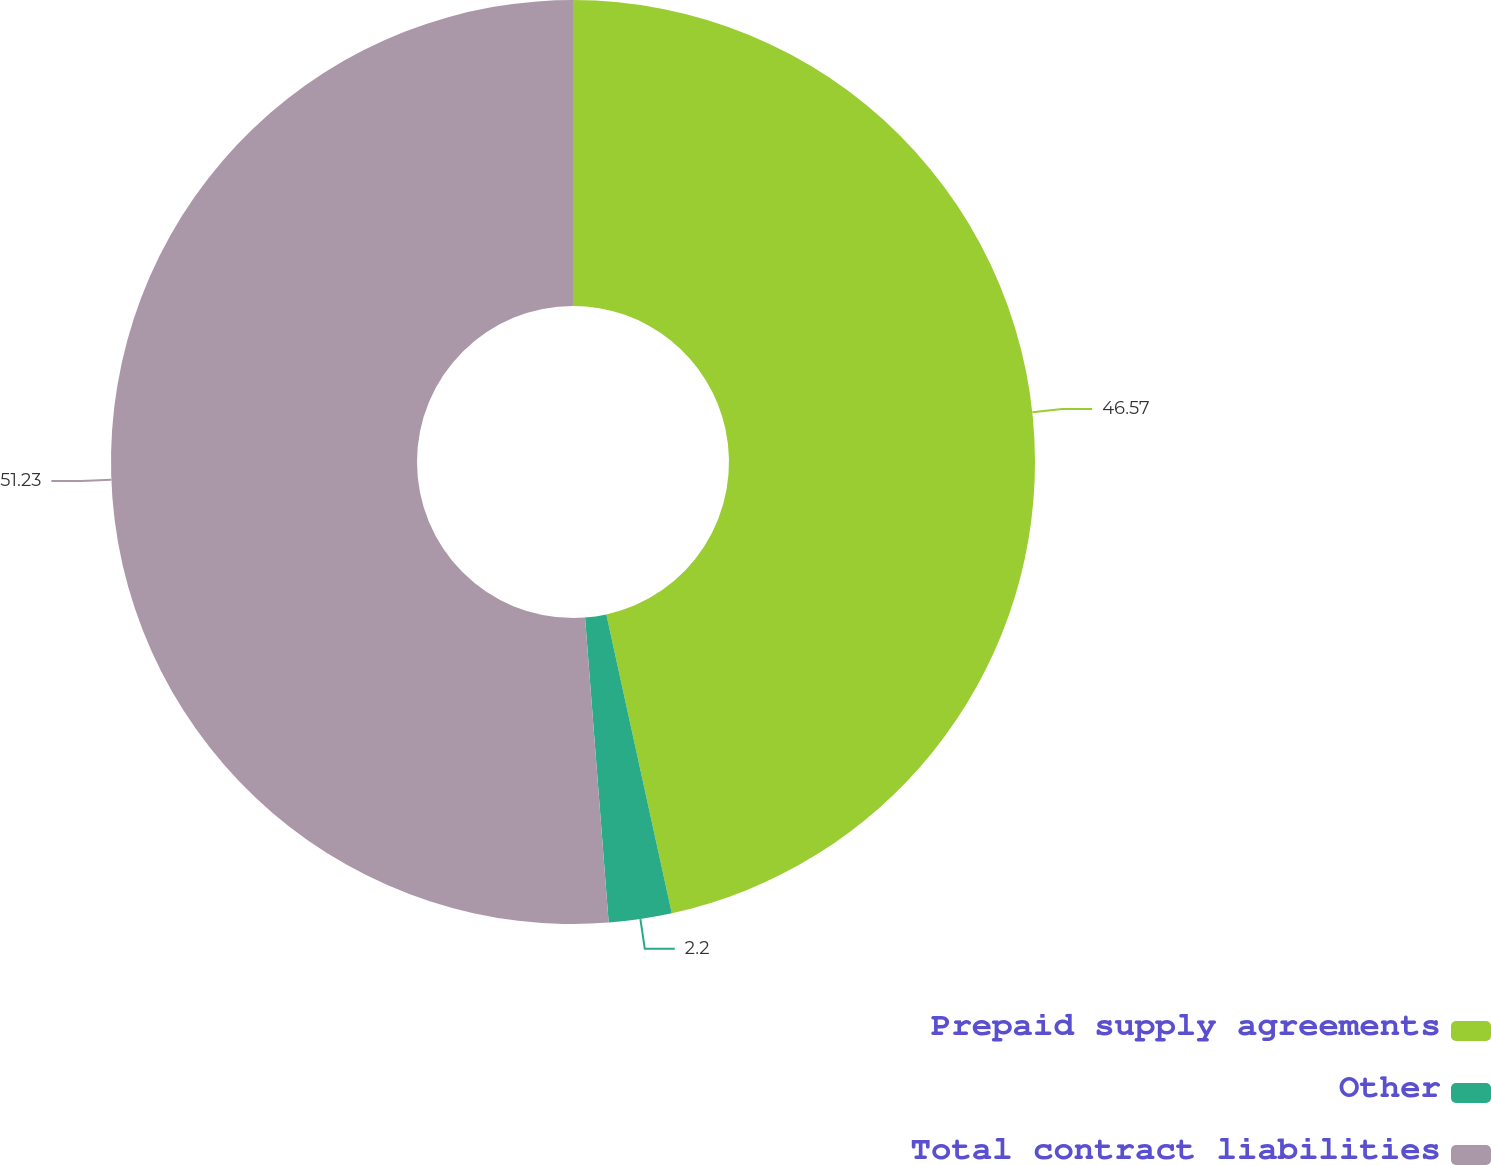Convert chart to OTSL. <chart><loc_0><loc_0><loc_500><loc_500><pie_chart><fcel>Prepaid supply agreements<fcel>Other<fcel>Total contract liabilities<nl><fcel>46.57%<fcel>2.2%<fcel>51.23%<nl></chart> 